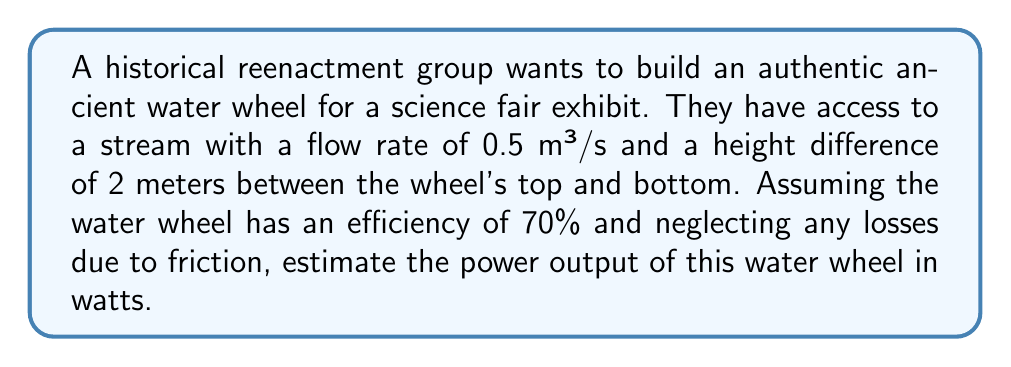Could you help me with this problem? Let's approach this problem step-by-step using principles of fluid dynamics and energy conversion:

1) First, we need to calculate the potential energy of the water per unit time. The formula for potential energy is:

   $$PE = mgh$$

   where $m$ is mass, $g$ is acceleration due to gravity, and $h$ is height difference.

2) We're given the flow rate in volume per time, so we need to convert this to mass per time. The density of water is approximately 1000 kg/m³. So:

   $$\text{Mass flow rate} = 0.5 \text{ m³/s} \times 1000 \text{ kg/m³} = 500 \text{ kg/s}$$

3) Now we can calculate the potential energy per second (which is equivalent to power):

   $$P_\text{potential} = 500 \text{ kg/s} \times 9.81 \text{ m/s²} \times 2 \text{ m} = 9810 \text{ W}$$

4) This is the theoretical maximum power available. However, the water wheel has an efficiency of 70%. To find the actual power output, we multiply by the efficiency:

   $$P_\text{actual} = 9810 \text{ W} \times 0.70 = 6867 \text{ W}$$

5) Rounding to a reasonable number of significant figures, we get approximately 6870 W or 6.87 kW.
Answer: 6870 W 